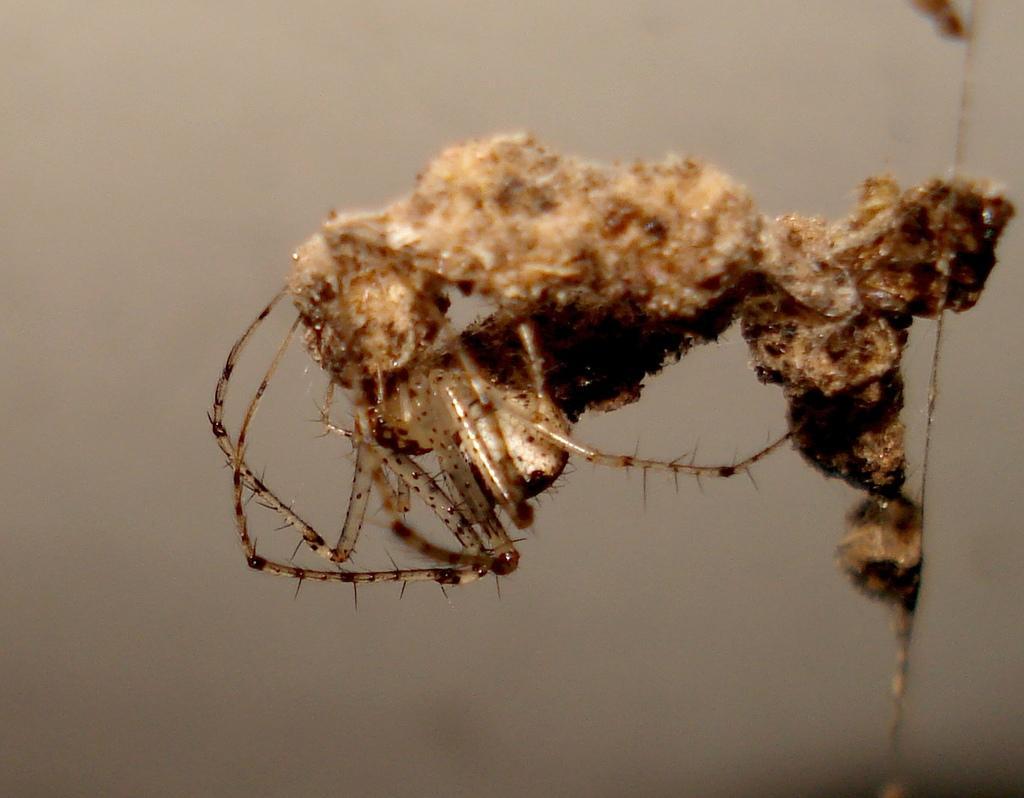Could you give a brief overview of what you see in this image? In this image in the front there is an insect and the background is blurry. 